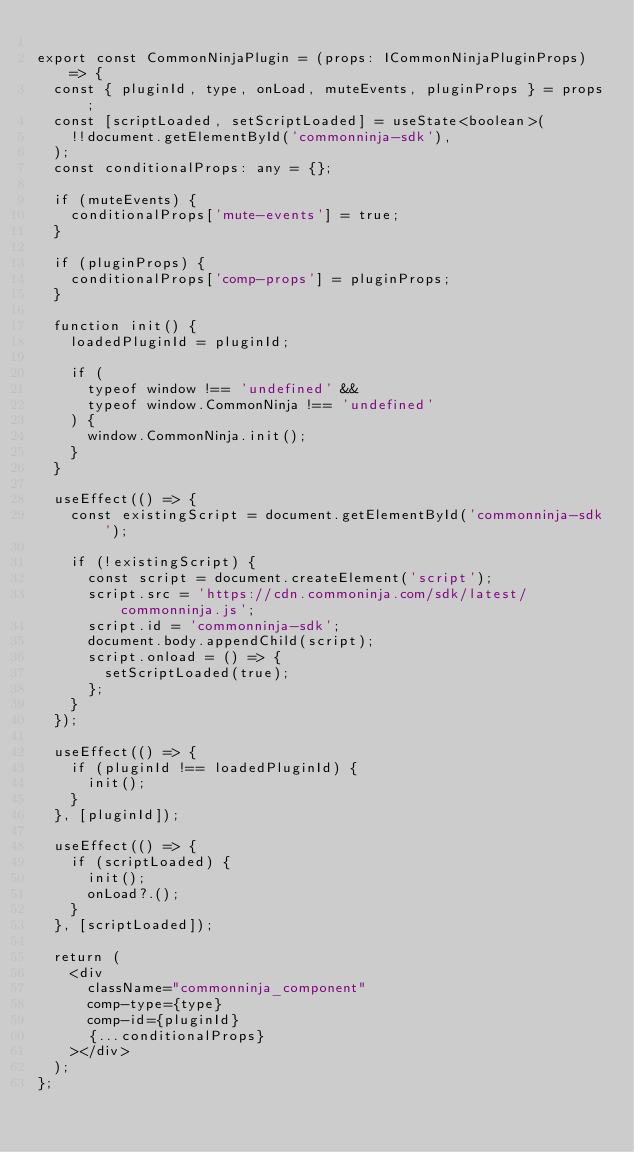Convert code to text. <code><loc_0><loc_0><loc_500><loc_500><_TypeScript_>
export const CommonNinjaPlugin = (props: ICommonNinjaPluginProps) => {
  const { pluginId, type, onLoad, muteEvents, pluginProps } = props;
  const [scriptLoaded, setScriptLoaded] = useState<boolean>(
    !!document.getElementById('commonninja-sdk'),
  );
  const conditionalProps: any = {};

  if (muteEvents) {
    conditionalProps['mute-events'] = true;
  }

  if (pluginProps) {
    conditionalProps['comp-props'] = pluginProps;
  }

  function init() {
    loadedPluginId = pluginId;

    if (
      typeof window !== 'undefined' &&
      typeof window.CommonNinja !== 'undefined'
    ) {
      window.CommonNinja.init();
    }
  }

  useEffect(() => {
    const existingScript = document.getElementById('commonninja-sdk');

    if (!existingScript) {
      const script = document.createElement('script');
      script.src = 'https://cdn.commoninja.com/sdk/latest/commonninja.js';
      script.id = 'commonninja-sdk';
      document.body.appendChild(script);
      script.onload = () => {
        setScriptLoaded(true);
      };
    }
  });

  useEffect(() => {
    if (pluginId !== loadedPluginId) {
      init();
    }
  }, [pluginId]);

  useEffect(() => {
    if (scriptLoaded) {
      init();
      onLoad?.();
    }
  }, [scriptLoaded]);

  return (
    <div
      className="commonninja_component"
      comp-type={type}
      comp-id={pluginId}
      {...conditionalProps}
    ></div>
  );
};
</code> 